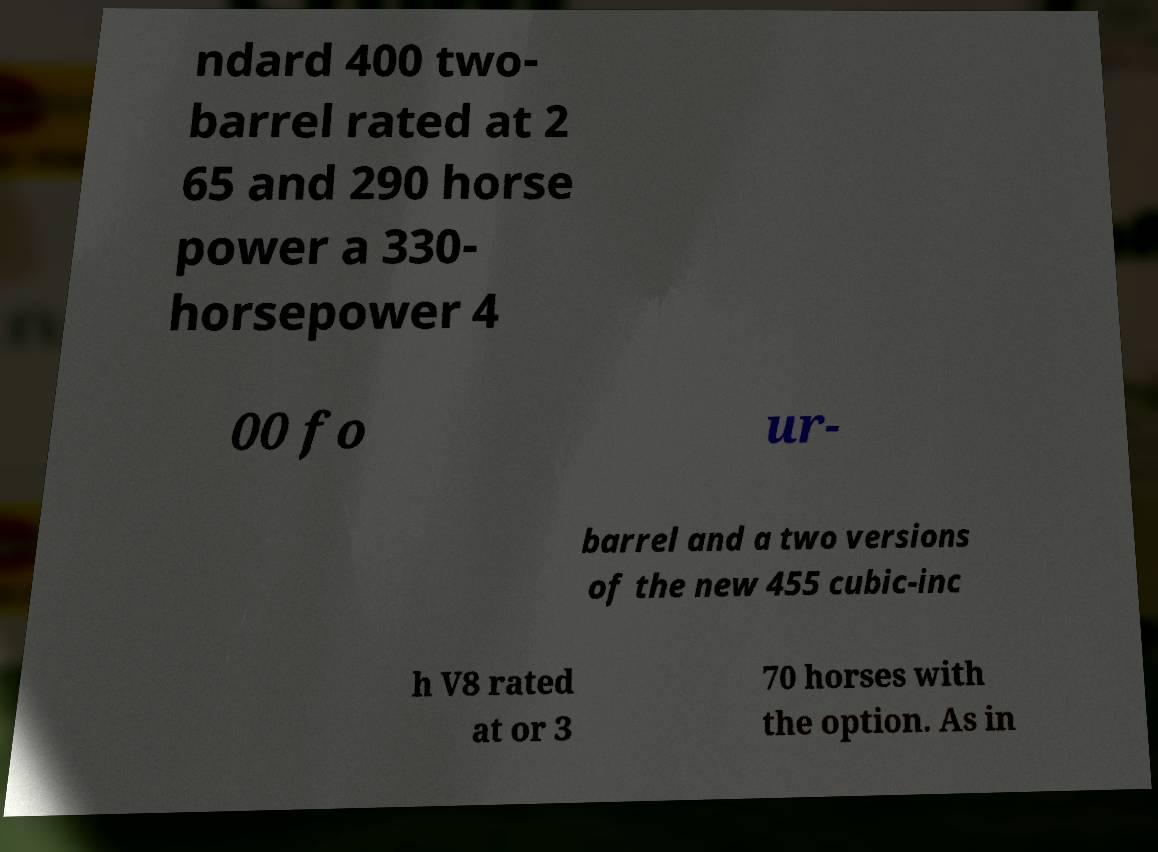Could you assist in decoding the text presented in this image and type it out clearly? ndard 400 two- barrel rated at 2 65 and 290 horse power a 330- horsepower 4 00 fo ur- barrel and a two versions of the new 455 cubic-inc h V8 rated at or 3 70 horses with the option. As in 